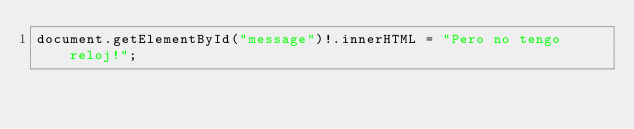<code> <loc_0><loc_0><loc_500><loc_500><_TypeScript_>document.getElementById("message")!.innerHTML = "Pero no tengo reloj!";</code> 